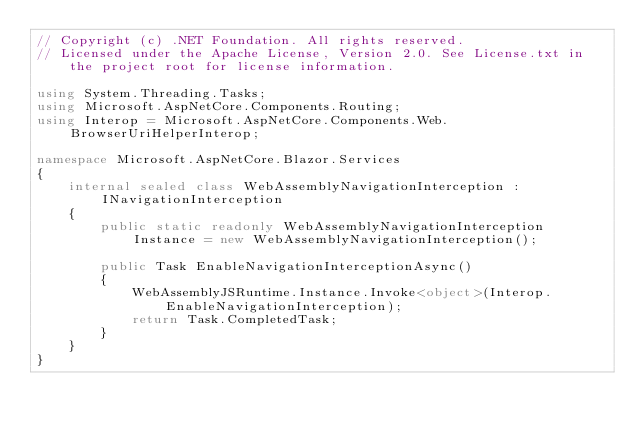<code> <loc_0><loc_0><loc_500><loc_500><_C#_>// Copyright (c) .NET Foundation. All rights reserved.
// Licensed under the Apache License, Version 2.0. See License.txt in the project root for license information.

using System.Threading.Tasks;
using Microsoft.AspNetCore.Components.Routing;
using Interop = Microsoft.AspNetCore.Components.Web.BrowserUriHelperInterop;

namespace Microsoft.AspNetCore.Blazor.Services
{
    internal sealed class WebAssemblyNavigationInterception : INavigationInterception
    {
        public static readonly WebAssemblyNavigationInterception Instance = new WebAssemblyNavigationInterception();

        public Task EnableNavigationInterceptionAsync()
        {
            WebAssemblyJSRuntime.Instance.Invoke<object>(Interop.EnableNavigationInterception);
            return Task.CompletedTask;
        }
    }
}
</code> 